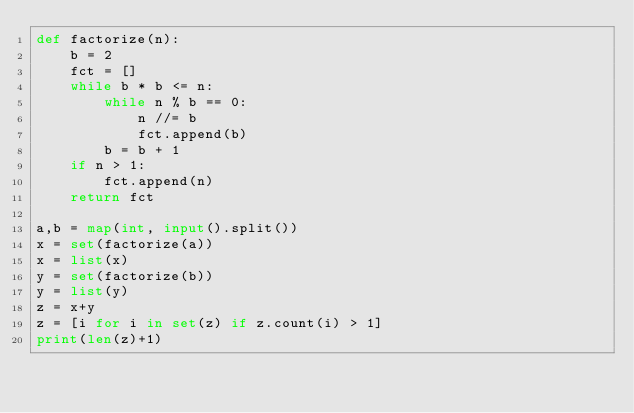<code> <loc_0><loc_0><loc_500><loc_500><_Python_>def factorize(n):
    b = 2
    fct = []
    while b * b <= n:
        while n % b == 0:
            n //= b
            fct.append(b)
        b = b + 1
    if n > 1:
        fct.append(n)
    return fct

a,b = map(int, input().split())
x = set(factorize(a))
x = list(x)
y = set(factorize(b))
y = list(y)
z = x+y
z = [i for i in set(z) if z.count(i) > 1]
print(len(z)+1)</code> 